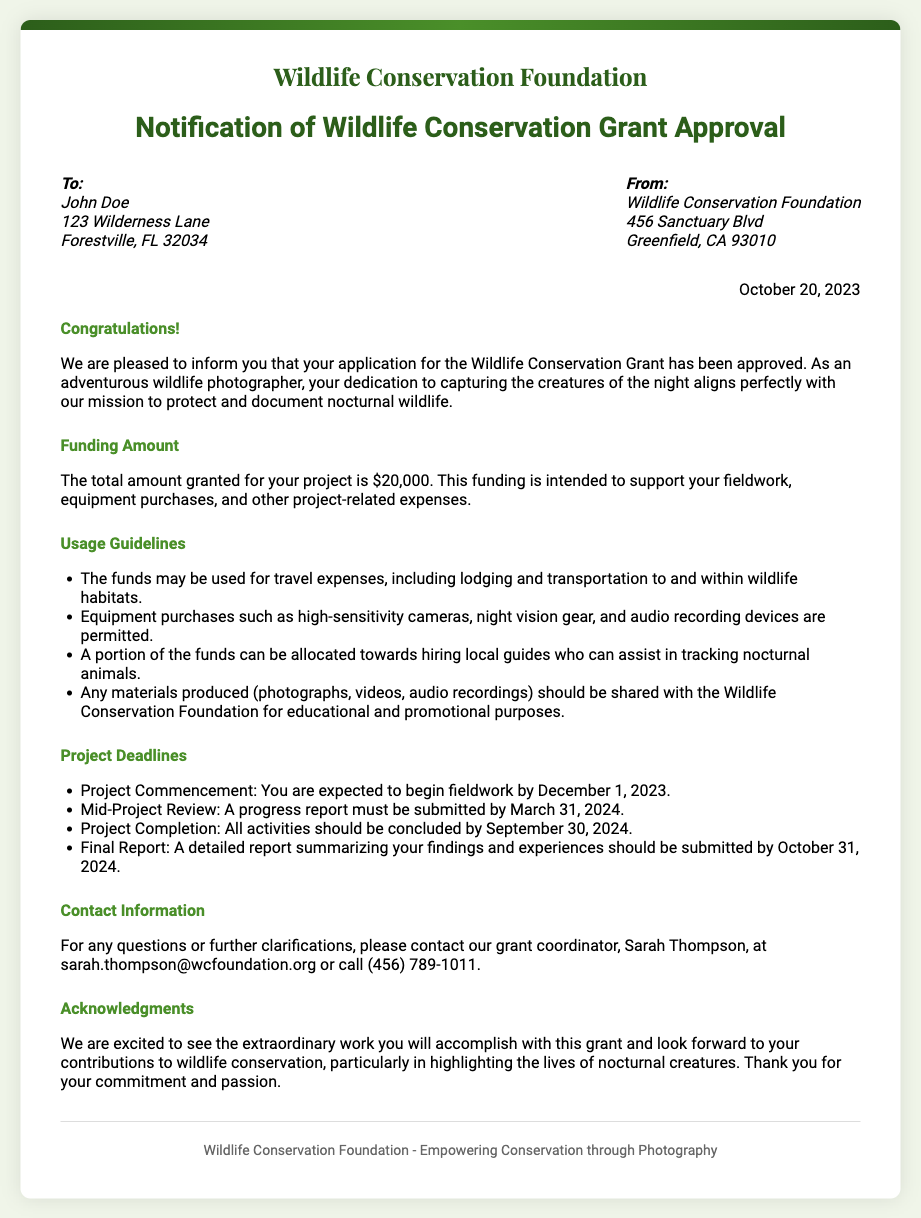What is the funding amount awarded? The funding amount is explicitly stated in the document as $20,000.
Answer: $20,000 What is the project commencement date? The document specifies the expected start date for fieldwork as December 1, 2023.
Answer: December 1, 2023 Who is the grant coordinator's contact person? The document lists Sarah Thompson as the grant coordinator along with her contact details.
Answer: Sarah Thompson What is required by March 31, 2024? The document states that a progress report must be submitted by that date.
Answer: Progress report What should be submitted by October 31, 2024? The document indicates that a detailed report summarizing the findings and experiences is due.
Answer: Final report How should the produced materials be used? The document outlines that any materials produced should be shared with the Wildlife Conservation Foundation for educational and promotional purposes.
Answer: Shared with the Wildlife Conservation Foundation What type of equipment purchases are permitted? The document specifically mentions high-sensitivity cameras and night vision gear as allowed equipment purchases.
Answer: High-sensitivity cameras, night vision gear What is the purpose of the funding? The document states the funding is intended to support fieldwork and project-related expenses.
Answer: Support fieldwork, project-related expenses What is emphasized about the photographer's work? The document highlights that the photographer's dedication aligns with the mission to protect nocturnal wildlife.
Answer: Protect and document nocturnal wildlife 